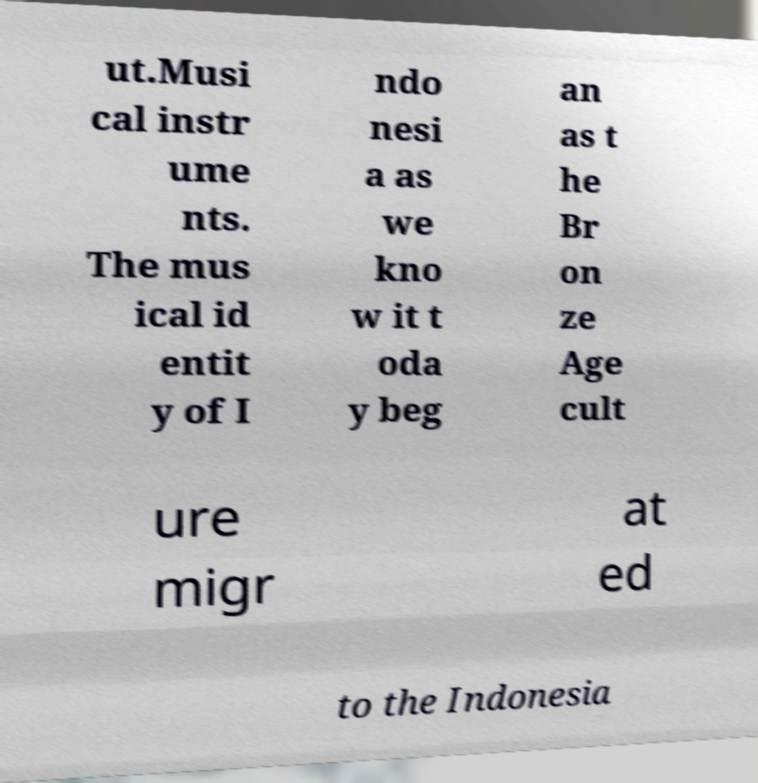I need the written content from this picture converted into text. Can you do that? ut.Musi cal instr ume nts. The mus ical id entit y of I ndo nesi a as we kno w it t oda y beg an as t he Br on ze Age cult ure migr at ed to the Indonesia 